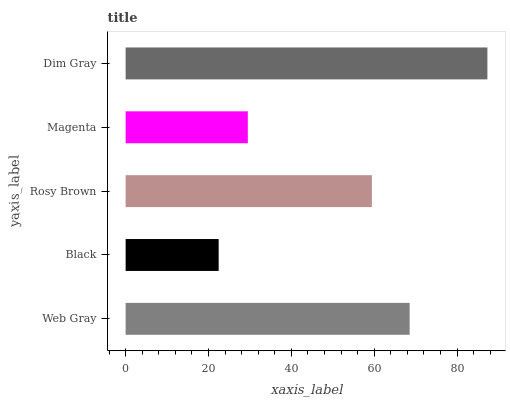Is Black the minimum?
Answer yes or no. Yes. Is Dim Gray the maximum?
Answer yes or no. Yes. Is Rosy Brown the minimum?
Answer yes or no. No. Is Rosy Brown the maximum?
Answer yes or no. No. Is Rosy Brown greater than Black?
Answer yes or no. Yes. Is Black less than Rosy Brown?
Answer yes or no. Yes. Is Black greater than Rosy Brown?
Answer yes or no. No. Is Rosy Brown less than Black?
Answer yes or no. No. Is Rosy Brown the high median?
Answer yes or no. Yes. Is Rosy Brown the low median?
Answer yes or no. Yes. Is Magenta the high median?
Answer yes or no. No. Is Black the low median?
Answer yes or no. No. 